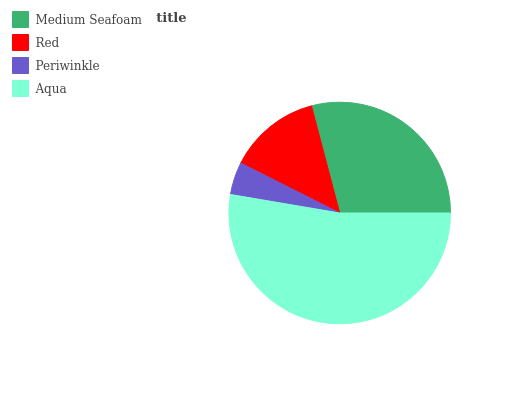Is Periwinkle the minimum?
Answer yes or no. Yes. Is Aqua the maximum?
Answer yes or no. Yes. Is Red the minimum?
Answer yes or no. No. Is Red the maximum?
Answer yes or no. No. Is Medium Seafoam greater than Red?
Answer yes or no. Yes. Is Red less than Medium Seafoam?
Answer yes or no. Yes. Is Red greater than Medium Seafoam?
Answer yes or no. No. Is Medium Seafoam less than Red?
Answer yes or no. No. Is Medium Seafoam the high median?
Answer yes or no. Yes. Is Red the low median?
Answer yes or no. Yes. Is Periwinkle the high median?
Answer yes or no. No. Is Medium Seafoam the low median?
Answer yes or no. No. 